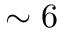Convert formula to latex. <formula><loc_0><loc_0><loc_500><loc_500>\sim 6</formula> 